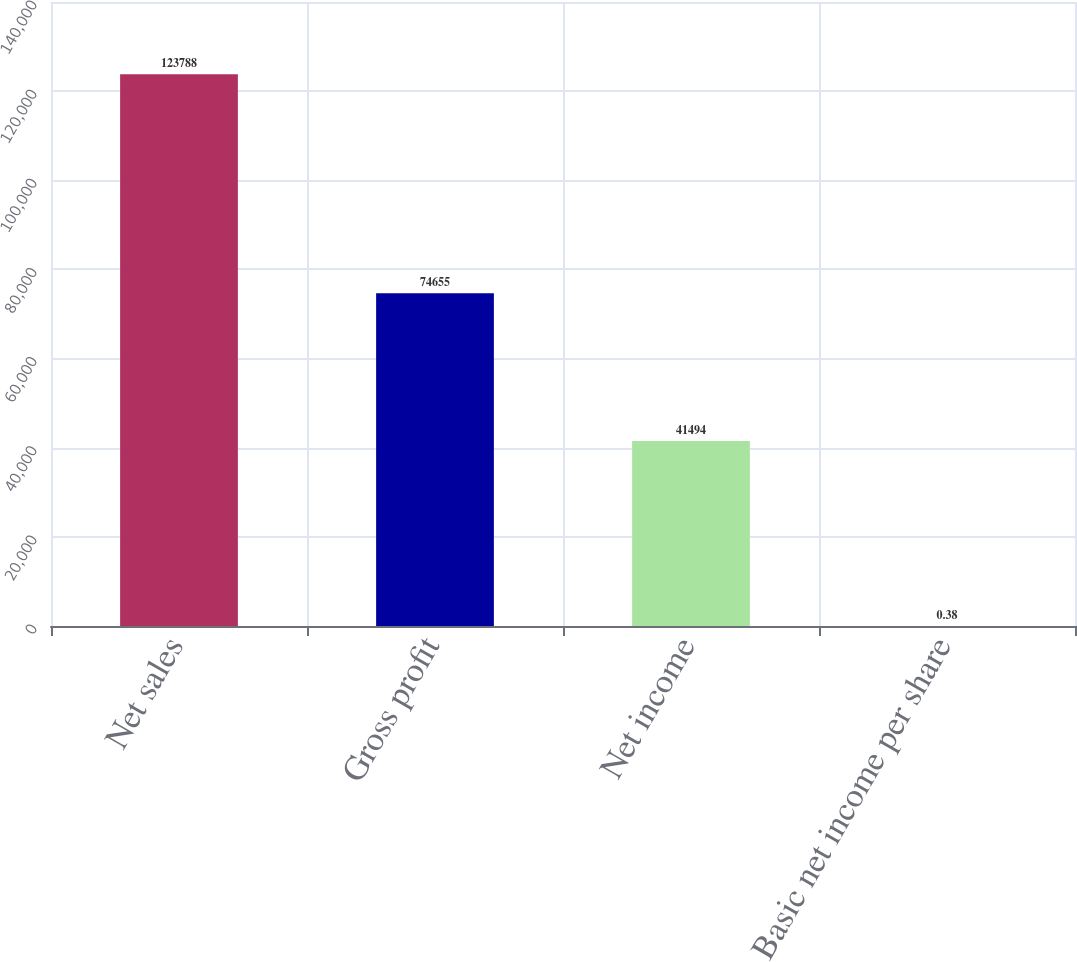Convert chart. <chart><loc_0><loc_0><loc_500><loc_500><bar_chart><fcel>Net sales<fcel>Gross profit<fcel>Net income<fcel>Basic net income per share<nl><fcel>123788<fcel>74655<fcel>41494<fcel>0.38<nl></chart> 